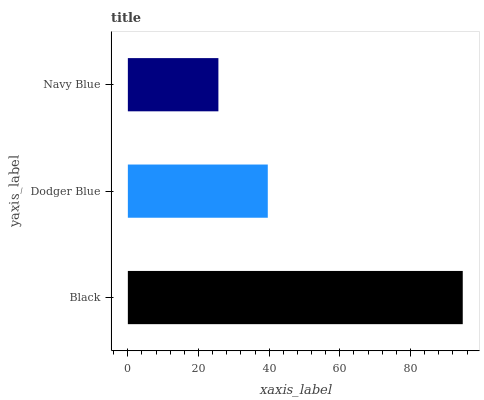Is Navy Blue the minimum?
Answer yes or no. Yes. Is Black the maximum?
Answer yes or no. Yes. Is Dodger Blue the minimum?
Answer yes or no. No. Is Dodger Blue the maximum?
Answer yes or no. No. Is Black greater than Dodger Blue?
Answer yes or no. Yes. Is Dodger Blue less than Black?
Answer yes or no. Yes. Is Dodger Blue greater than Black?
Answer yes or no. No. Is Black less than Dodger Blue?
Answer yes or no. No. Is Dodger Blue the high median?
Answer yes or no. Yes. Is Dodger Blue the low median?
Answer yes or no. Yes. Is Navy Blue the high median?
Answer yes or no. No. Is Black the low median?
Answer yes or no. No. 